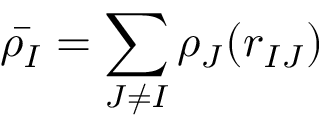<formula> <loc_0><loc_0><loc_500><loc_500>\bar { \rho _ { I } } = \sum _ { J \neq I } \rho _ { J } ( r _ { I J } )</formula> 